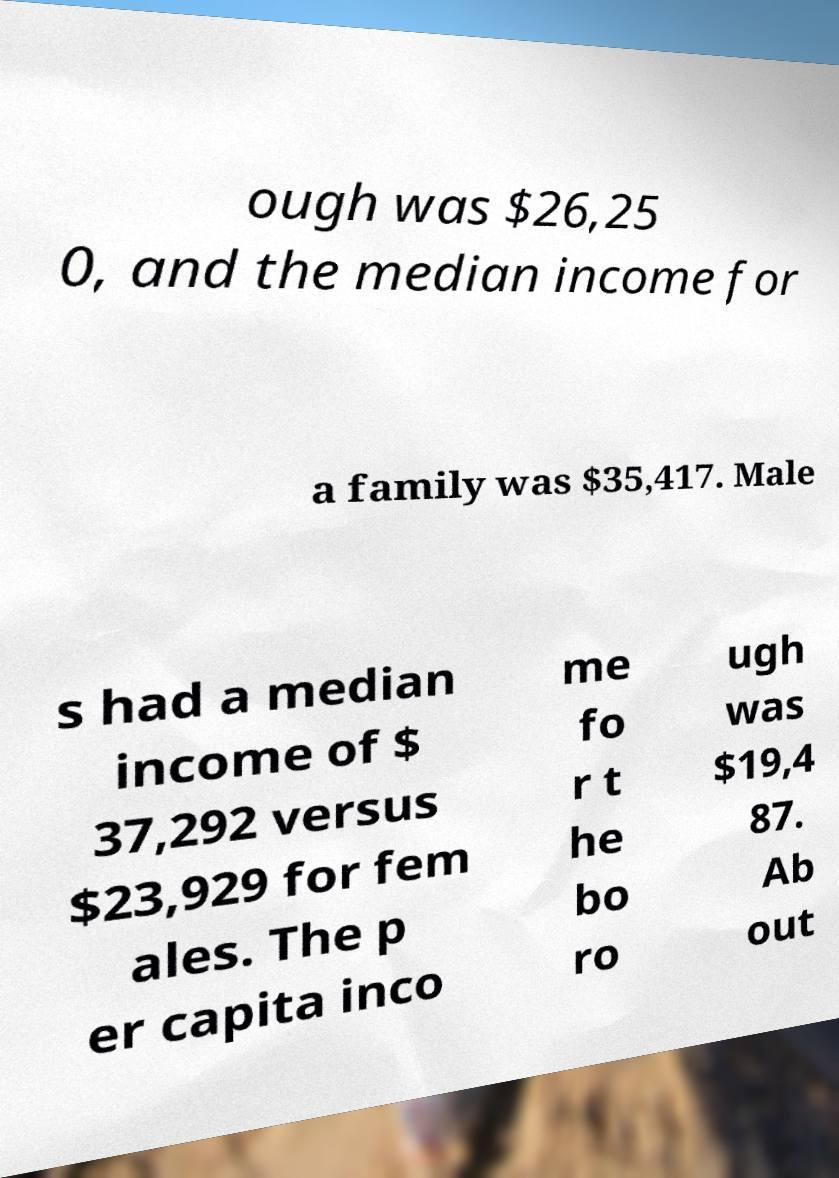Can you accurately transcribe the text from the provided image for me? ough was $26,25 0, and the median income for a family was $35,417. Male s had a median income of $ 37,292 versus $23,929 for fem ales. The p er capita inco me fo r t he bo ro ugh was $19,4 87. Ab out 